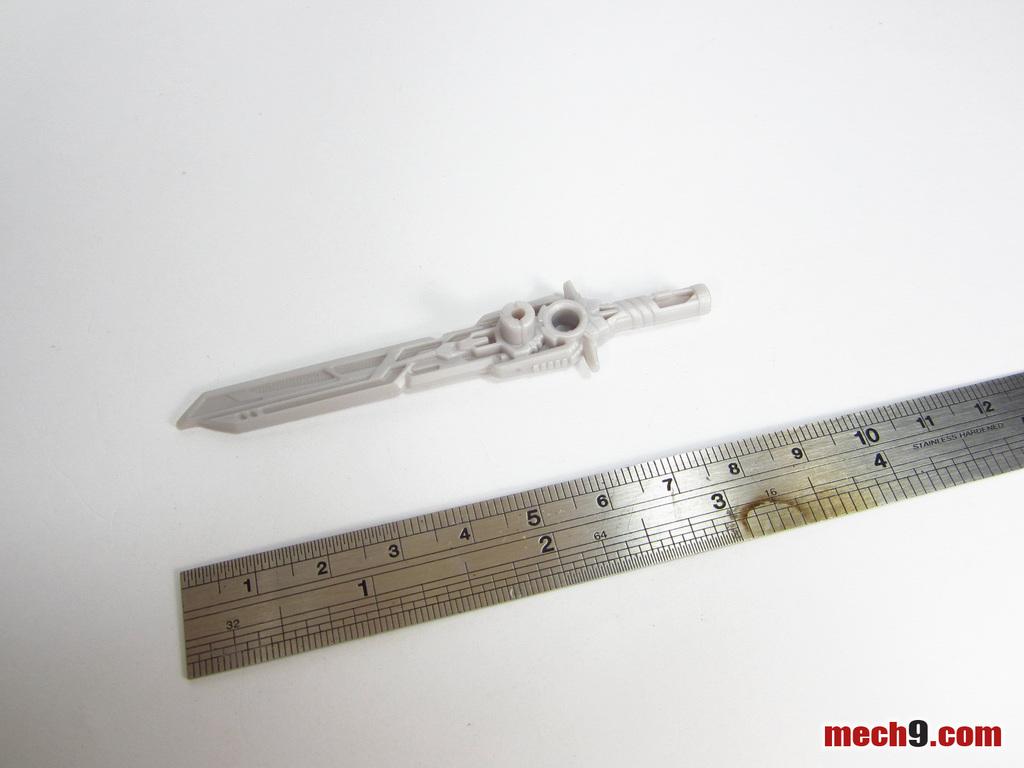What site is this from?
Make the answer very short. Mech9.com. 